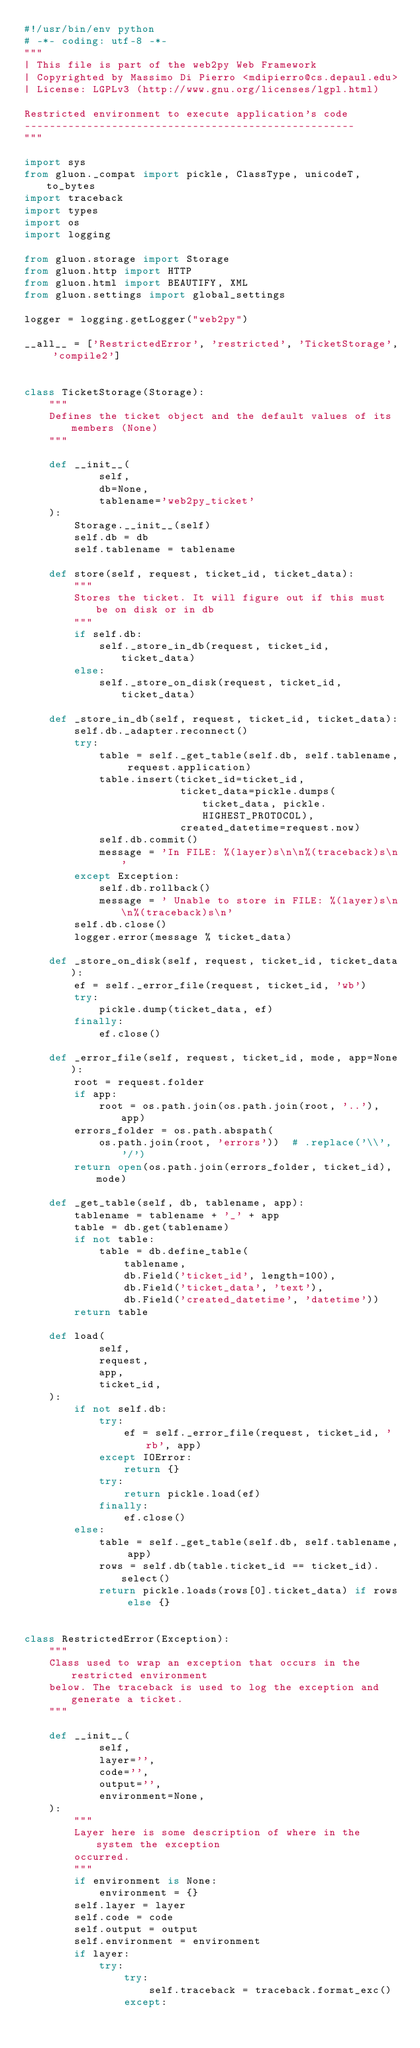Convert code to text. <code><loc_0><loc_0><loc_500><loc_500><_Python_>#!/usr/bin/env python
# -*- coding: utf-8 -*-
"""
| This file is part of the web2py Web Framework
| Copyrighted by Massimo Di Pierro <mdipierro@cs.depaul.edu>
| License: LGPLv3 (http://www.gnu.org/licenses/lgpl.html)

Restricted environment to execute application's code
-----------------------------------------------------
"""

import sys
from gluon._compat import pickle, ClassType, unicodeT, to_bytes
import traceback
import types
import os
import logging

from gluon.storage import Storage
from gluon.http import HTTP
from gluon.html import BEAUTIFY, XML
from gluon.settings import global_settings

logger = logging.getLogger("web2py")

__all__ = ['RestrictedError', 'restricted', 'TicketStorage', 'compile2']


class TicketStorage(Storage):
    """
    Defines the ticket object and the default values of its members (None)
    """

    def __init__(
            self,
            db=None,
            tablename='web2py_ticket'
    ):
        Storage.__init__(self)
        self.db = db
        self.tablename = tablename

    def store(self, request, ticket_id, ticket_data):
        """
        Stores the ticket. It will figure out if this must be on disk or in db
        """
        if self.db:
            self._store_in_db(request, ticket_id, ticket_data)
        else:
            self._store_on_disk(request, ticket_id, ticket_data)

    def _store_in_db(self, request, ticket_id, ticket_data):
        self.db._adapter.reconnect()
        try:
            table = self._get_table(self.db, self.tablename, request.application)
            table.insert(ticket_id=ticket_id,
                         ticket_data=pickle.dumps(ticket_data, pickle.HIGHEST_PROTOCOL),
                         created_datetime=request.now)
            self.db.commit()
            message = 'In FILE: %(layer)s\n\n%(traceback)s\n'
        except Exception:
            self.db.rollback()
            message = ' Unable to store in FILE: %(layer)s\n\n%(traceback)s\n'
        self.db.close()
        logger.error(message % ticket_data)

    def _store_on_disk(self, request, ticket_id, ticket_data):
        ef = self._error_file(request, ticket_id, 'wb')
        try:
            pickle.dump(ticket_data, ef)
        finally:
            ef.close()

    def _error_file(self, request, ticket_id, mode, app=None):
        root = request.folder
        if app:
            root = os.path.join(os.path.join(root, '..'), app)
        errors_folder = os.path.abspath(
            os.path.join(root, 'errors'))  # .replace('\\', '/')
        return open(os.path.join(errors_folder, ticket_id), mode)

    def _get_table(self, db, tablename, app):
        tablename = tablename + '_' + app
        table = db.get(tablename)
        if not table:
            table = db.define_table(
                tablename,
                db.Field('ticket_id', length=100),
                db.Field('ticket_data', 'text'),
                db.Field('created_datetime', 'datetime'))
        return table

    def load(
            self,
            request,
            app,
            ticket_id,
    ):
        if not self.db:
            try:
                ef = self._error_file(request, ticket_id, 'rb', app)
            except IOError:
                return {}
            try:
                return pickle.load(ef)
            finally:
                ef.close()
        else:
            table = self._get_table(self.db, self.tablename, app)
            rows = self.db(table.ticket_id == ticket_id).select()
            return pickle.loads(rows[0].ticket_data) if rows else {}


class RestrictedError(Exception):
    """
    Class used to wrap an exception that occurs in the restricted environment
    below. The traceback is used to log the exception and generate a ticket.
    """

    def __init__(
            self,
            layer='',
            code='',
            output='',
            environment=None,
    ):
        """
        Layer here is some description of where in the system the exception
        occurred.
        """
        if environment is None:
            environment = {}
        self.layer = layer
        self.code = code
        self.output = output
        self.environment = environment
        if layer:
            try:
                try:
                    self.traceback = traceback.format_exc()
                except:</code> 